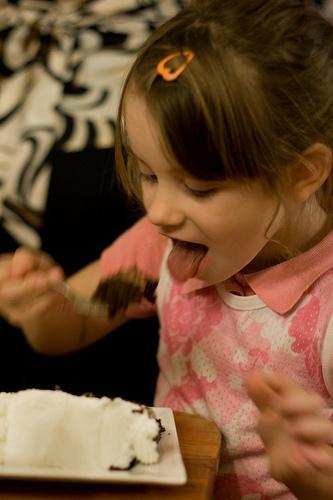How many cakes are present?
Give a very brief answer. 1. 